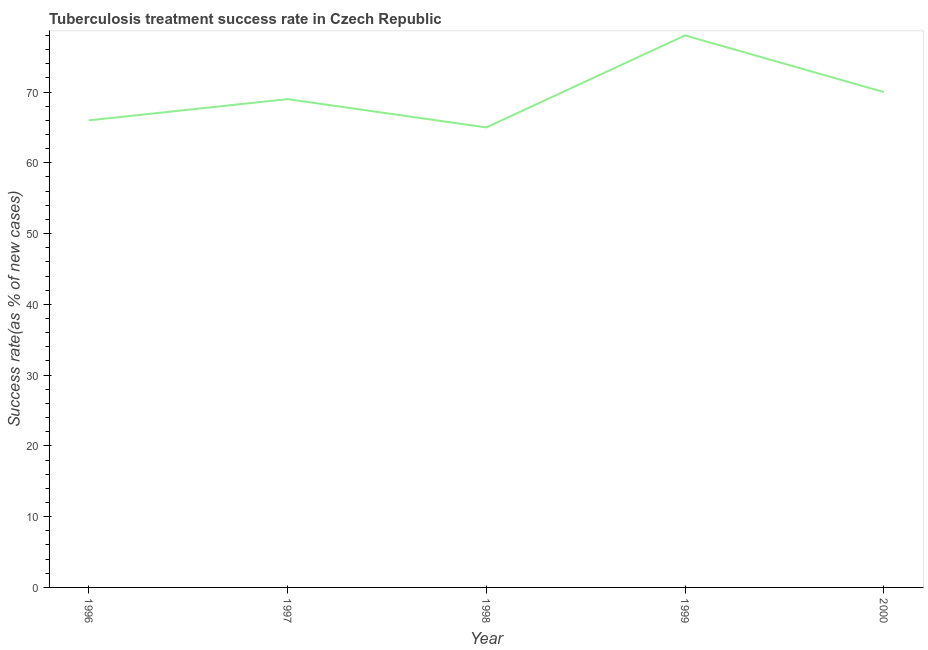What is the tuberculosis treatment success rate in 1997?
Keep it short and to the point. 69. Across all years, what is the maximum tuberculosis treatment success rate?
Your answer should be very brief. 78. Across all years, what is the minimum tuberculosis treatment success rate?
Keep it short and to the point. 65. What is the sum of the tuberculosis treatment success rate?
Provide a short and direct response. 348. What is the difference between the tuberculosis treatment success rate in 1997 and 1999?
Your answer should be compact. -9. What is the average tuberculosis treatment success rate per year?
Your response must be concise. 69.6. What is the median tuberculosis treatment success rate?
Make the answer very short. 69. What is the ratio of the tuberculosis treatment success rate in 1999 to that in 2000?
Your answer should be very brief. 1.11. Is the difference between the tuberculosis treatment success rate in 1997 and 1999 greater than the difference between any two years?
Keep it short and to the point. No. What is the difference between the highest and the lowest tuberculosis treatment success rate?
Your answer should be very brief. 13. Does the tuberculosis treatment success rate monotonically increase over the years?
Make the answer very short. No. How many lines are there?
Offer a very short reply. 1. How many years are there in the graph?
Make the answer very short. 5. Are the values on the major ticks of Y-axis written in scientific E-notation?
Keep it short and to the point. No. What is the title of the graph?
Keep it short and to the point. Tuberculosis treatment success rate in Czech Republic. What is the label or title of the X-axis?
Ensure brevity in your answer.  Year. What is the label or title of the Y-axis?
Keep it short and to the point. Success rate(as % of new cases). What is the Success rate(as % of new cases) of 1998?
Provide a short and direct response. 65. What is the Success rate(as % of new cases) of 1999?
Offer a terse response. 78. What is the Success rate(as % of new cases) of 2000?
Your answer should be compact. 70. What is the difference between the Success rate(as % of new cases) in 1996 and 1997?
Make the answer very short. -3. What is the difference between the Success rate(as % of new cases) in 1996 and 1998?
Your answer should be very brief. 1. What is the difference between the Success rate(as % of new cases) in 1996 and 1999?
Make the answer very short. -12. What is the difference between the Success rate(as % of new cases) in 1997 and 1998?
Keep it short and to the point. 4. What is the difference between the Success rate(as % of new cases) in 1997 and 2000?
Provide a succinct answer. -1. What is the difference between the Success rate(as % of new cases) in 1999 and 2000?
Provide a short and direct response. 8. What is the ratio of the Success rate(as % of new cases) in 1996 to that in 1997?
Offer a terse response. 0.96. What is the ratio of the Success rate(as % of new cases) in 1996 to that in 1999?
Make the answer very short. 0.85. What is the ratio of the Success rate(as % of new cases) in 1996 to that in 2000?
Your answer should be compact. 0.94. What is the ratio of the Success rate(as % of new cases) in 1997 to that in 1998?
Offer a terse response. 1.06. What is the ratio of the Success rate(as % of new cases) in 1997 to that in 1999?
Your response must be concise. 0.89. What is the ratio of the Success rate(as % of new cases) in 1998 to that in 1999?
Offer a terse response. 0.83. What is the ratio of the Success rate(as % of new cases) in 1998 to that in 2000?
Provide a short and direct response. 0.93. What is the ratio of the Success rate(as % of new cases) in 1999 to that in 2000?
Your answer should be compact. 1.11. 